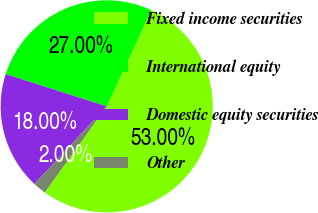<chart> <loc_0><loc_0><loc_500><loc_500><pie_chart><fcel>Fixed income securities<fcel>International equity<fcel>Domestic equity securities<fcel>Other<nl><fcel>53.0%<fcel>27.0%<fcel>18.0%<fcel>2.0%<nl></chart> 